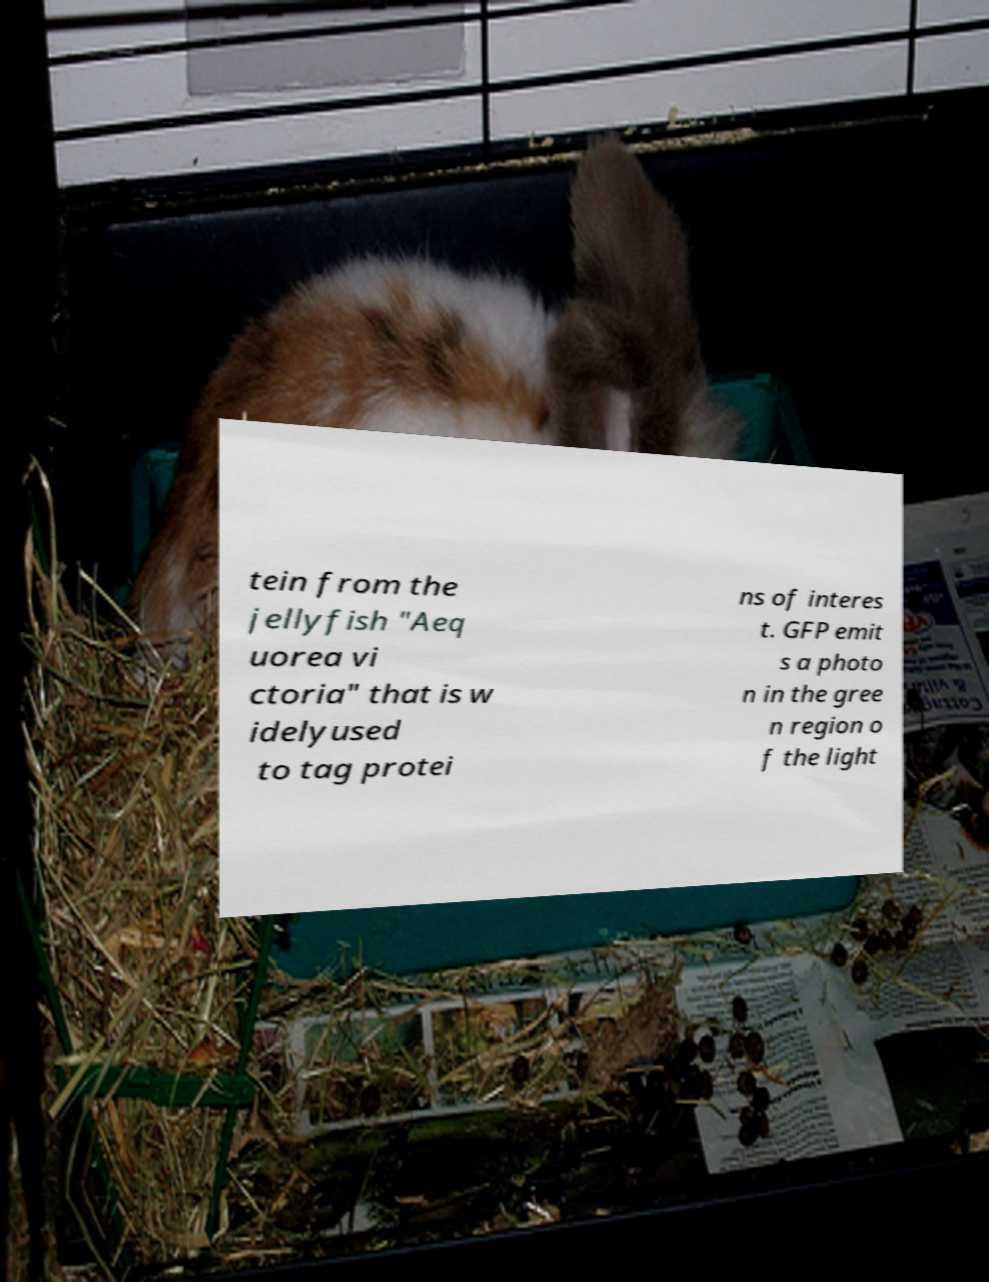Can you accurately transcribe the text from the provided image for me? tein from the jellyfish "Aeq uorea vi ctoria" that is w idelyused to tag protei ns of interes t. GFP emit s a photo n in the gree n region o f the light 